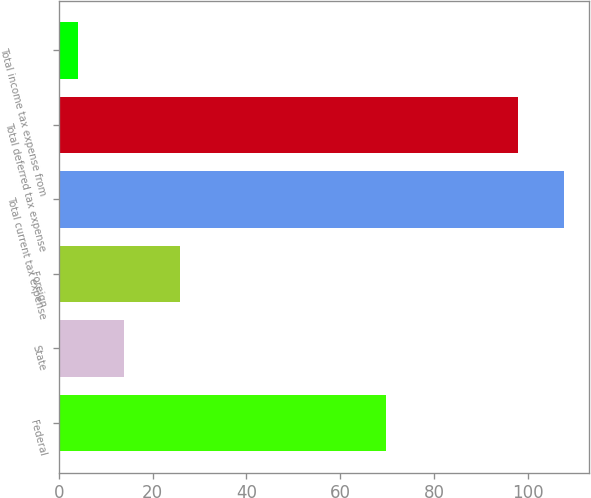Convert chart. <chart><loc_0><loc_0><loc_500><loc_500><bar_chart><fcel>Federal<fcel>State<fcel>Foreign<fcel>Total current tax expense<fcel>Total deferred tax expense<fcel>Total income tax expense from<nl><fcel>69.8<fcel>13.99<fcel>25.8<fcel>107.69<fcel>97.9<fcel>4.2<nl></chart> 